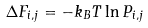<formula> <loc_0><loc_0><loc_500><loc_500>\Delta F _ { i , j } = - k _ { B } T \ln P _ { i , j }</formula> 